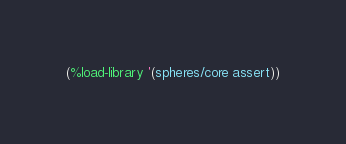<code> <loc_0><loc_0><loc_500><loc_500><_Scheme_>(%load-library '(spheres/core assert))
</code> 